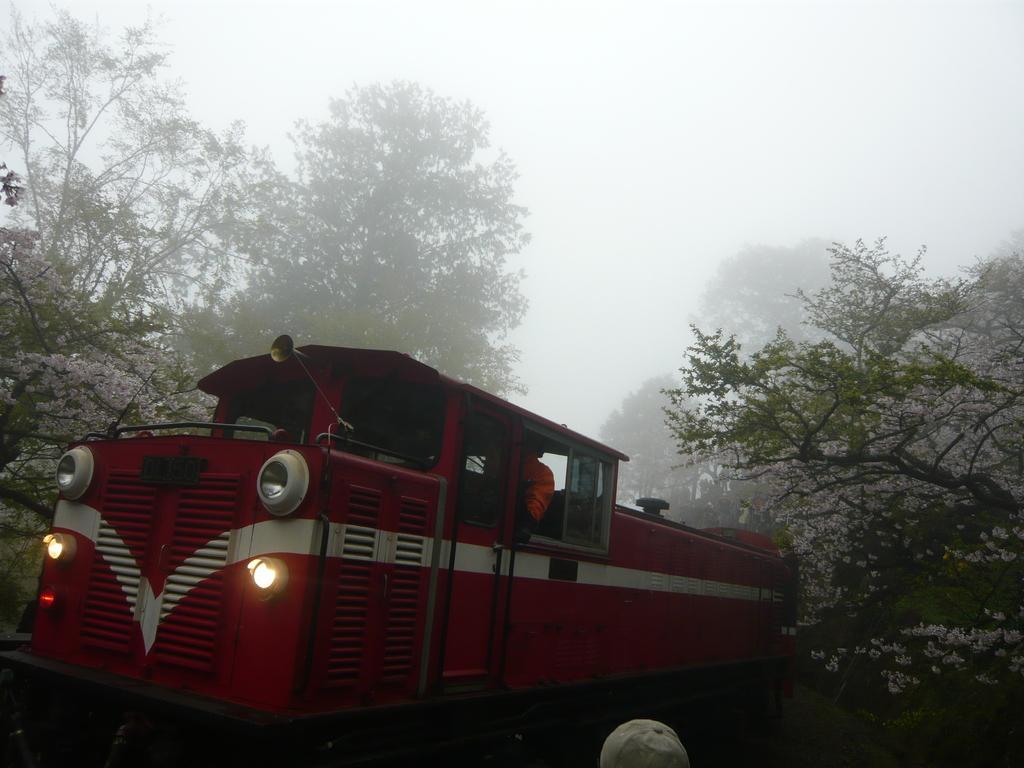How would you summarize this image in a sentence or two? In this image there is a train in the middle. There are two headlights to the train. In the background there are trees. At the bottom there is a cap. At the top there is fog. 